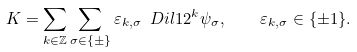Convert formula to latex. <formula><loc_0><loc_0><loc_500><loc_500>K = \sum _ { k \in \mathbb { Z } } \sum _ { \sigma \in \{ \pm \} } \varepsilon _ { k , \sigma } \ D i l 1 { 2 ^ { k } } \psi _ { \sigma } , \quad \varepsilon _ { k , \sigma } \in \{ \pm 1 \} .</formula> 